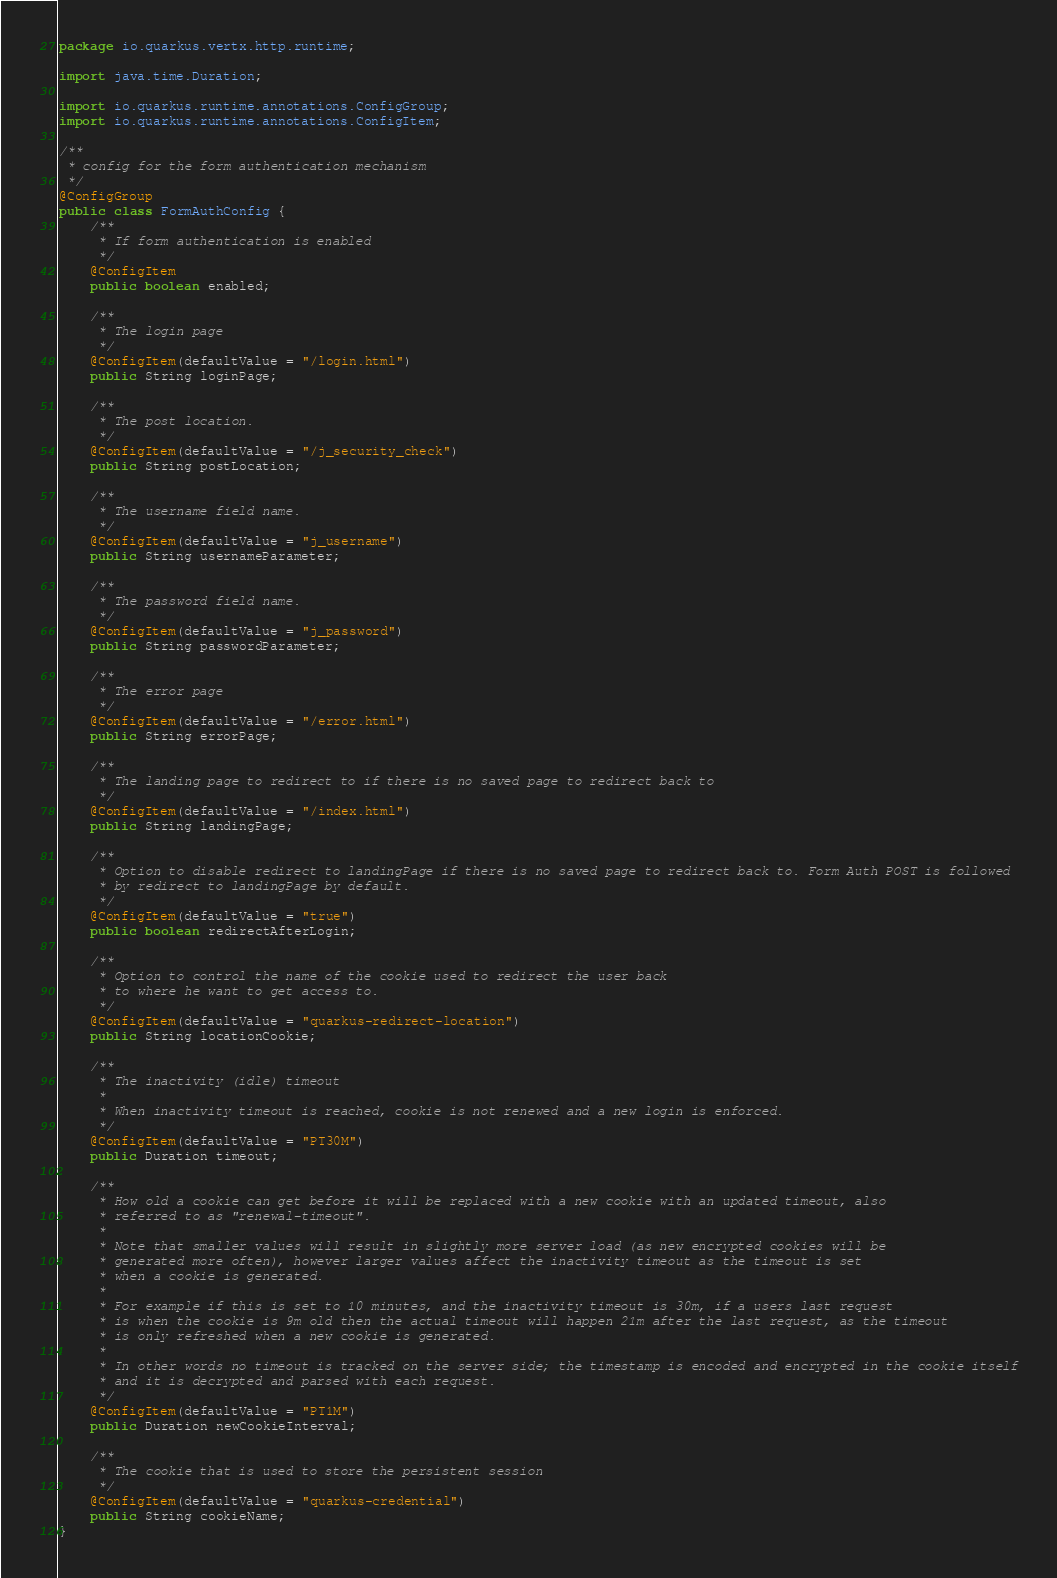Convert code to text. <code><loc_0><loc_0><loc_500><loc_500><_Java_>package io.quarkus.vertx.http.runtime;

import java.time.Duration;

import io.quarkus.runtime.annotations.ConfigGroup;
import io.quarkus.runtime.annotations.ConfigItem;

/**
 * config for the form authentication mechanism
 */
@ConfigGroup
public class FormAuthConfig {
    /**
     * If form authentication is enabled
     */
    @ConfigItem
    public boolean enabled;

    /**
     * The login page
     */
    @ConfigItem(defaultValue = "/login.html")
    public String loginPage;

    /**
     * The post location.
     */
    @ConfigItem(defaultValue = "/j_security_check")
    public String postLocation;

    /**
     * The username field name.
     */
    @ConfigItem(defaultValue = "j_username")
    public String usernameParameter;

    /**
     * The password field name.
     */
    @ConfigItem(defaultValue = "j_password")
    public String passwordParameter;

    /**
     * The error page
     */
    @ConfigItem(defaultValue = "/error.html")
    public String errorPage;

    /**
     * The landing page to redirect to if there is no saved page to redirect back to
     */
    @ConfigItem(defaultValue = "/index.html")
    public String landingPage;

    /**
     * Option to disable redirect to landingPage if there is no saved page to redirect back to. Form Auth POST is followed
     * by redirect to landingPage by default.
     */
    @ConfigItem(defaultValue = "true")
    public boolean redirectAfterLogin;

    /**
     * Option to control the name of the cookie used to redirect the user back
     * to where he want to get access to.
     */
    @ConfigItem(defaultValue = "quarkus-redirect-location")
    public String locationCookie;

    /**
     * The inactivity (idle) timeout
     *
     * When inactivity timeout is reached, cookie is not renewed and a new login is enforced.
     */
    @ConfigItem(defaultValue = "PT30M")
    public Duration timeout;

    /**
     * How old a cookie can get before it will be replaced with a new cookie with an updated timeout, also
     * referred to as "renewal-timeout".
     *
     * Note that smaller values will result in slightly more server load (as new encrypted cookies will be
     * generated more often), however larger values affect the inactivity timeout as the timeout is set
     * when a cookie is generated.
     *
     * For example if this is set to 10 minutes, and the inactivity timeout is 30m, if a users last request
     * is when the cookie is 9m old then the actual timeout will happen 21m after the last request, as the timeout
     * is only refreshed when a new cookie is generated.
     *
     * In other words no timeout is tracked on the server side; the timestamp is encoded and encrypted in the cookie itself
     * and it is decrypted and parsed with each request.
     */
    @ConfigItem(defaultValue = "PT1M")
    public Duration newCookieInterval;

    /**
     * The cookie that is used to store the persistent session
     */
    @ConfigItem(defaultValue = "quarkus-credential")
    public String cookieName;
}
</code> 